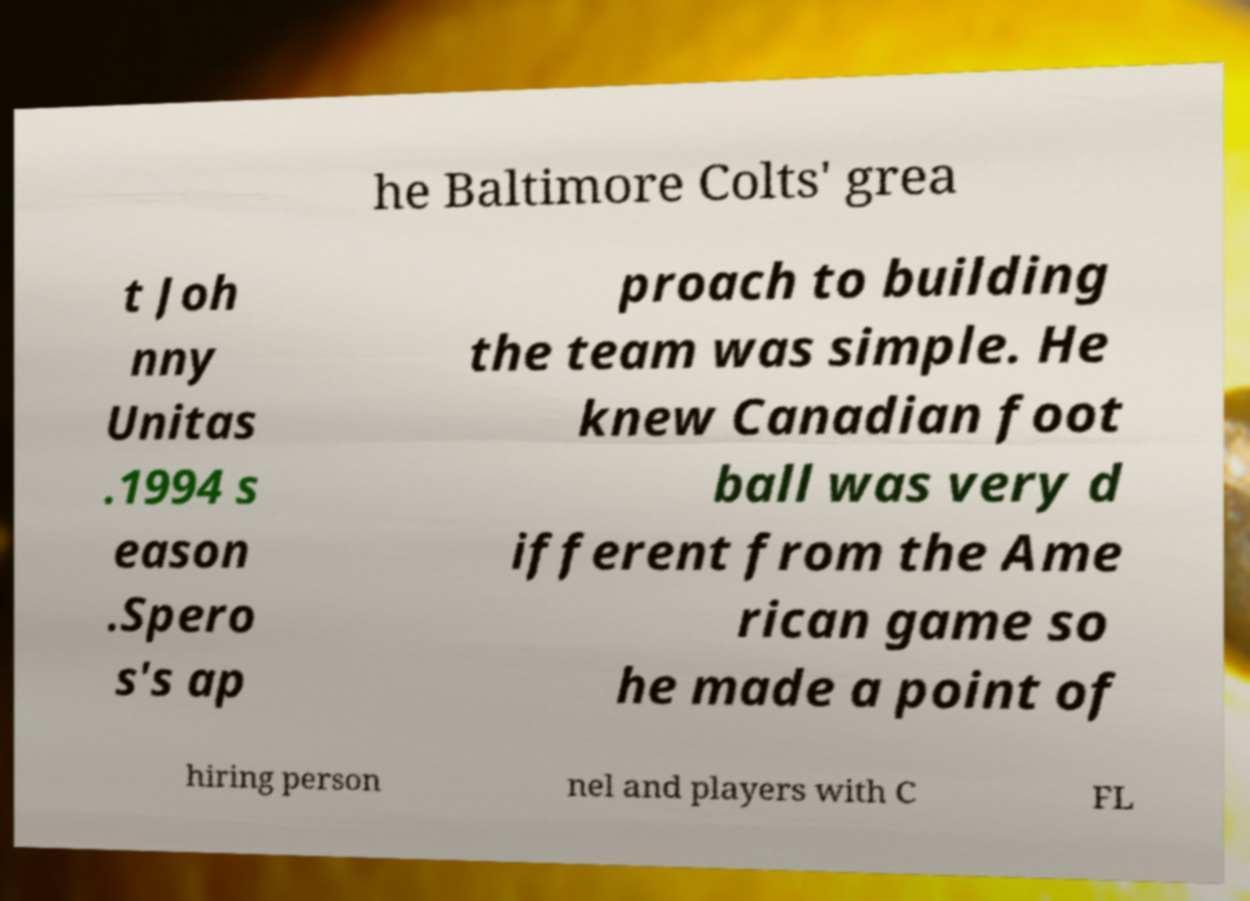I need the written content from this picture converted into text. Can you do that? he Baltimore Colts' grea t Joh nny Unitas .1994 s eason .Spero s's ap proach to building the team was simple. He knew Canadian foot ball was very d ifferent from the Ame rican game so he made a point of hiring person nel and players with C FL 